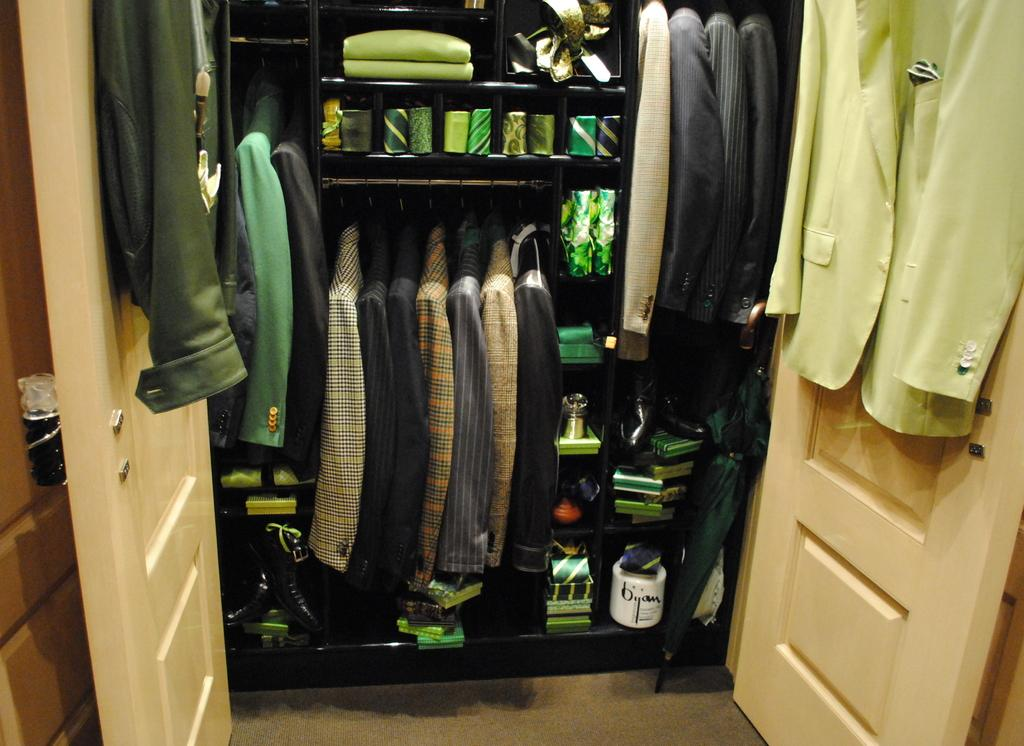What type of items can be seen in the image? There are clothes and boxes in the image. Can you describe the white-colored thing in the image? There is a white-colored thing in the image, but it is not clear what it is from the provided facts. How many doors are visible in the image? There are two doors on both sides of the image. What type of bucket is being used by the porter in the image? There is no bucket or porter present in the image. What type of structure is depicted in the image? The provided facts do not give enough information to determine the type of structure depicted in the image. 